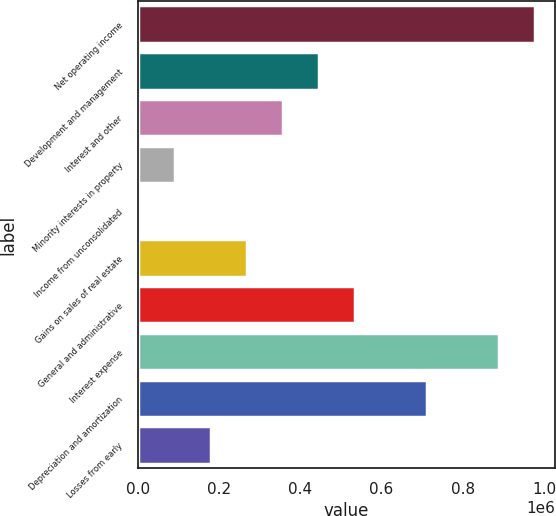<chart> <loc_0><loc_0><loc_500><loc_500><bar_chart><fcel>Net operating income<fcel>Development and management<fcel>Interest and other<fcel>Minority interests in property<fcel>Income from unconsolidated<fcel>Gains on sales of real estate<fcel>General and administrative<fcel>Interest expense<fcel>Depreciation and amortization<fcel>Losses from early<nl><fcel>978440<fcel>446589<fcel>357947<fcel>92021.8<fcel>3380<fcel>269305<fcel>535231<fcel>889798<fcel>712514<fcel>180664<nl></chart> 